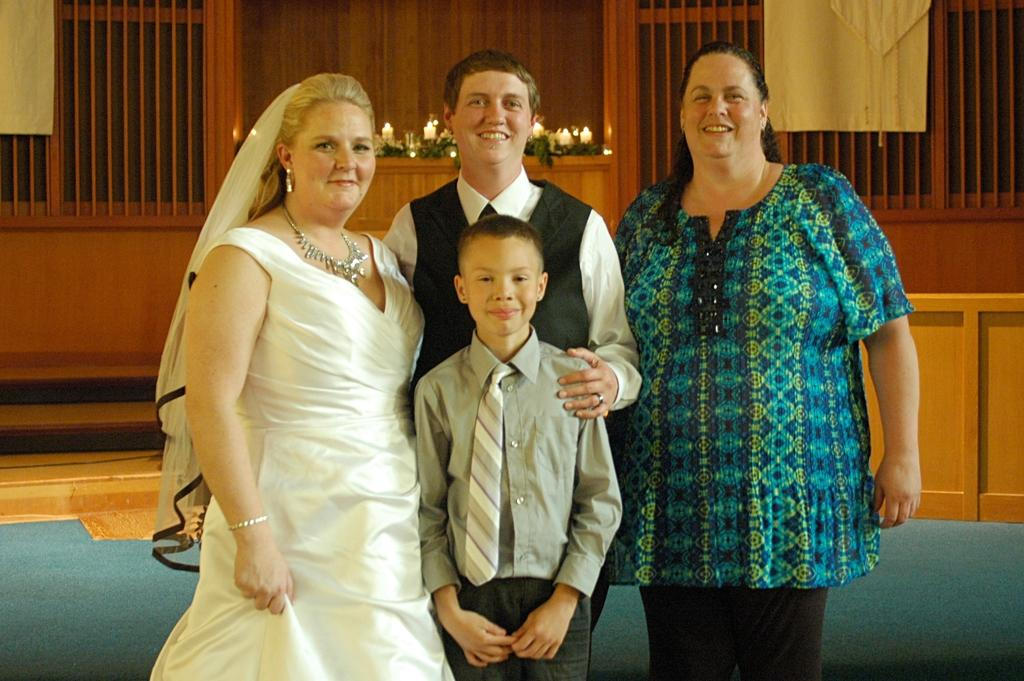What is happening in the image? There are people standing in the image. What can be seen in the background of the image? There is a wooden wall with wooden poles in the background. What objects in the image are producing light? There are candles with flames in the image. What type of curve can be seen in the image? There is no curve present in the image. What advice is being given in the image? There is no indication of any advice being given in the image. 